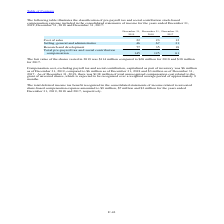According to Stmicroelectronics's financial document, What was the fair value of the shares vested in 2019? According to the financial document, $114 million. The relevant text states: "The fair value of the shares vested in 2019 was $114 million compared to $68 million for 2018 and $38 million for 2017...." Also, What was the compensation cost excluding payroll tax and social contribution, capitalised as a part of inventory as of 31 December 2019? According to the financial document, $6 million. The relevant text states: "contribution, capitalized as part of inventory was $6 million as of December 31, 2019, compared to $6 million as of December 31, 2018 and $3 million as of Decembe contribution, capitalized as part of ..." Also, What was the total deferred income tax benefit recognized in 019? According to the financial document, $9 million. The relevant text states: "ested share-based compensation expense amounted to $9 million, $7 million and $3 million for the years ended December 31, 2019, 2018 and 2017, respectively...." Also, can you calculate: What was the increase ./ (decrease) in the cost of sales from 2018 to 2019? Based on the calculation: 22 - 23, the result is -1 (in millions). This is based on the information: "Cost of sales 22 23 12 Cost of sales 22 23 12..." The key data points involved are: 22, 23. Also, can you calculate: What was the average of Selling, general and administrative? To answer this question, I need to perform calculations using the financial data. The calculation is: (46 + 67 + 31) / 3, which equals 48 (in millions). This is based on the information: "Selling, general and administrative 46 67 31 Selling, general and administrative 46 67 31 Selling, general and administrative 46 67 31..." The key data points involved are: 31, 46, 67. Also, can you calculate: What was the percentage increase / (decrease) in the Research and development from 2018 to 2019? To answer this question, I need to perform calculations using the financial data. The calculation is: 77 / 35 - 1, which equals 120 (percentage). This is based on the information: "Research and development 77 35 18 Research and development 77 35 18..." The key data points involved are: 35, 77. 